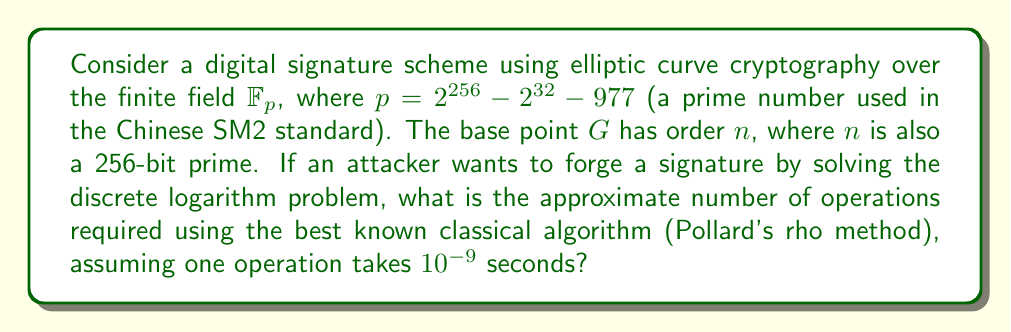What is the answer to this math problem? To analyze the security of this digital signature scheme, we need to consider the complexity of solving the discrete logarithm problem on the elliptic curve. The best known classical algorithm for this is Pollard's rho method.

Step 1: Determine the size of the problem
The order $n$ of the base point $G$ is a 256-bit prime, so the size of the problem is 256 bits.

Step 2: Calculate the number of operations for Pollard's rho method
Pollard's rho method has a time complexity of $O(\sqrt{n})$, where $n$ is the order of the base point. For a 256-bit prime $n$, this is approximately $2^{128}$ operations.

Step 3: Convert operations to time
Given that one operation takes $10^{-9}$ seconds:

Total time = $2^{128} \times 10^{-9}$ seconds

Step 4: Convert time to years for better understanding
Seconds in a year = $365 \times 24 \times 60 \times 60 = 31,536,000$

Years required = $\frac{2^{128} \times 10^{-9}}{31,536,000}$
               $\approx 1.08 \times 10^{31}$ years

This immense time frame demonstrates the high security level of the digital signature scheme, making it extremely difficult for an attacker to forge a signature using current classical computing methods.
Answer: $2^{128}$ operations, or approximately $1.08 \times 10^{31}$ years 